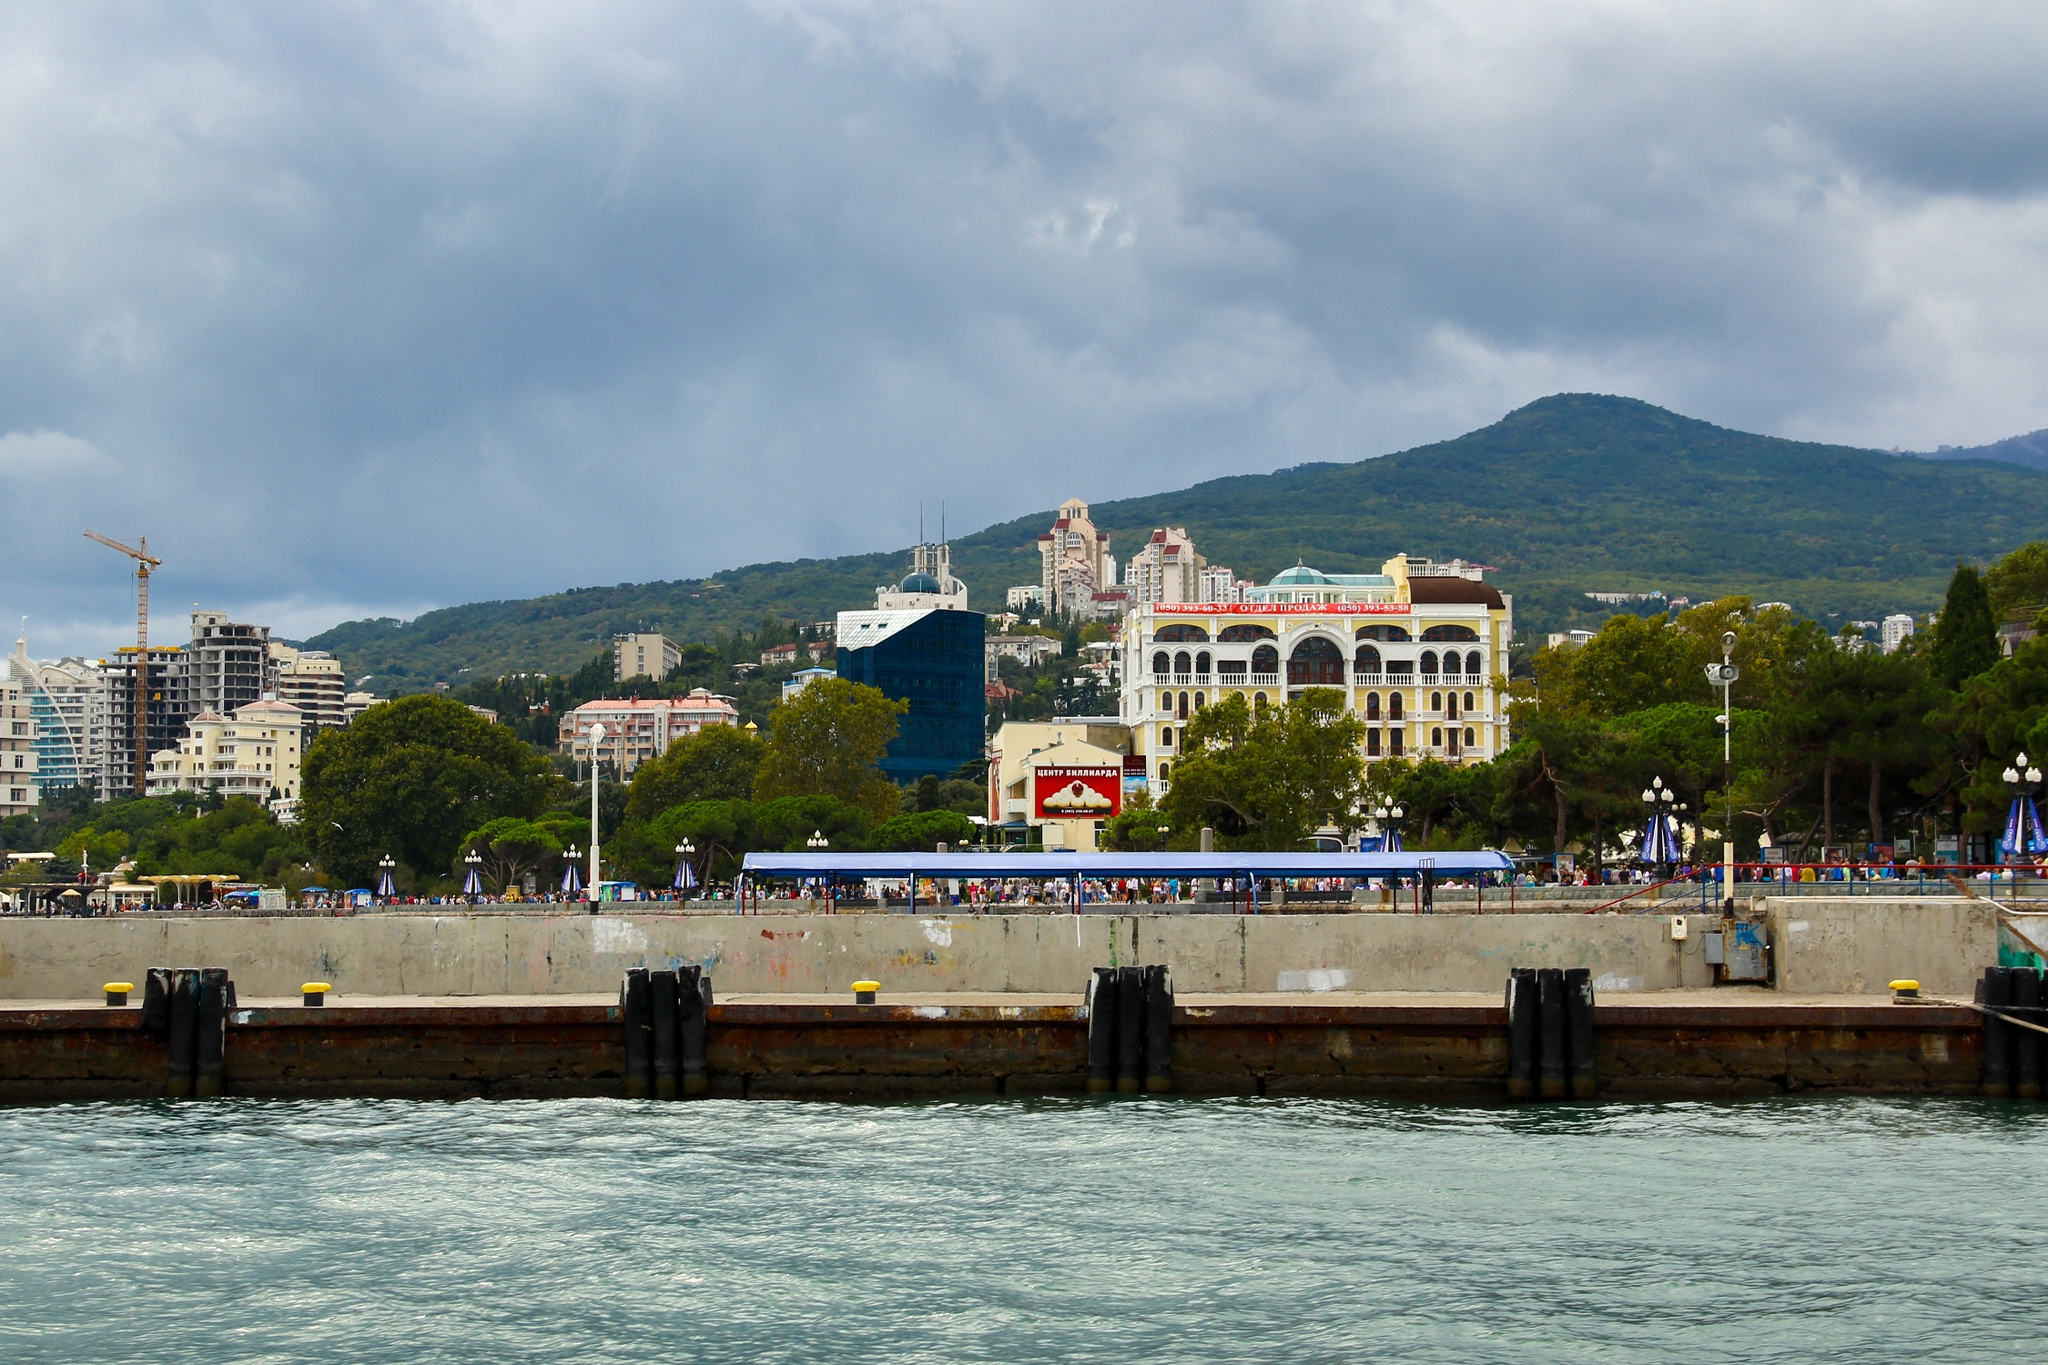Create a vivid and imaginative scenario involving this location. As twilight drapes the Yalta seafront in a golden hue, something extraordinary begins to unfold. The usual hustle and bustle fades, and the air takes on an enchanted quality. The white building with the red roof begins to shimmer, revealing itself as an ancient palace of mystical origins. The blue building beside it transforms, its walls becoming transparent and revealing an ethereal library filled with floating, glowing books. People on the pier stop and gaze in awe as the water starts glowing a brilliant turquoise, and luminescent mermaids emerge, singing an enchanting melody that mingles with the night air. This magical transformation happens only once every hundred years, a secret known to very few. Those lucky enough to witness it are said to carry a piece of its magic within them forever. 